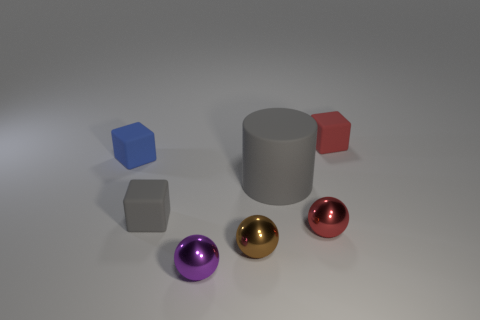Add 1 tiny red shiny balls. How many objects exist? 8 Subtract all cylinders. How many objects are left? 6 Subtract 2 balls. How many balls are left? 1 Add 1 blue matte objects. How many blue matte objects exist? 2 Subtract 0 gray balls. How many objects are left? 7 Subtract all red blocks. Subtract all cyan spheres. How many blocks are left? 2 Subtract all purple metallic objects. Subtract all large red rubber balls. How many objects are left? 6 Add 5 small blue rubber objects. How many small blue rubber objects are left? 6 